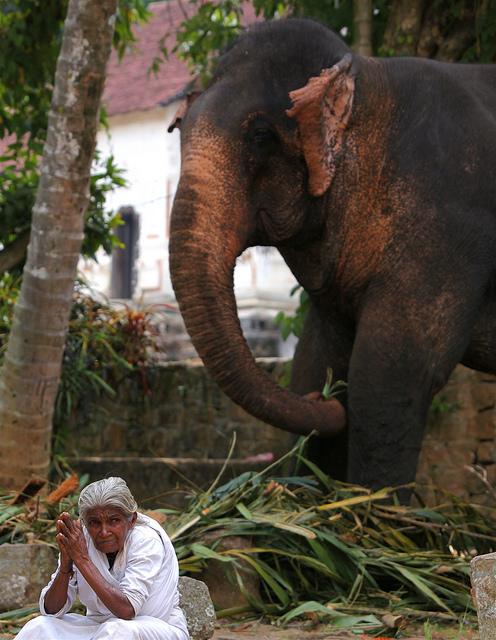Could the gray-haired man be a handler?
Give a very brief answer. Yes. Is the person wearing any black?
Concise answer only. No. What animal is behind the person?
Short answer required. Elephant. 